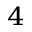<formula> <loc_0><loc_0><loc_500><loc_500>^ { 4 }</formula> 